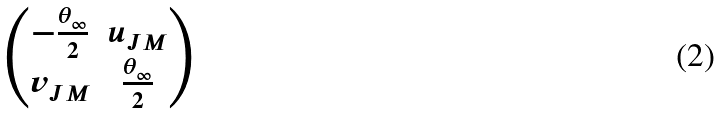Convert formula to latex. <formula><loc_0><loc_0><loc_500><loc_500>\begin{pmatrix} - \frac { \theta _ { \infty } } { 2 } & u _ { J M } \\ v _ { J M } & \frac { \theta _ { \infty } } { 2 } \end{pmatrix}</formula> 